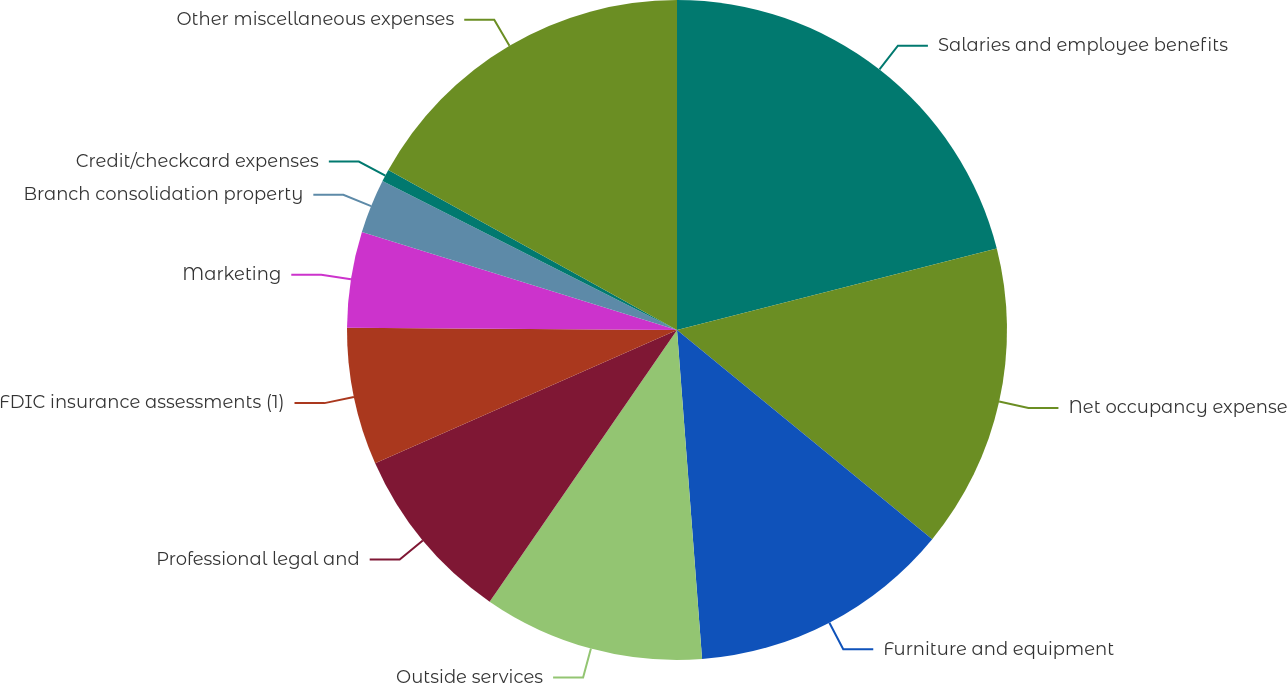Convert chart to OTSL. <chart><loc_0><loc_0><loc_500><loc_500><pie_chart><fcel>Salaries and employee benefits<fcel>Net occupancy expense<fcel>Furniture and equipment<fcel>Outside services<fcel>Professional legal and<fcel>FDIC insurance assessments (1)<fcel>Marketing<fcel>Branch consolidation property<fcel>Credit/checkcard expenses<fcel>Other miscellaneous expenses<nl><fcel>21.03%<fcel>14.9%<fcel>12.86%<fcel>10.82%<fcel>8.77%<fcel>6.73%<fcel>4.69%<fcel>2.65%<fcel>0.6%<fcel>16.95%<nl></chart> 